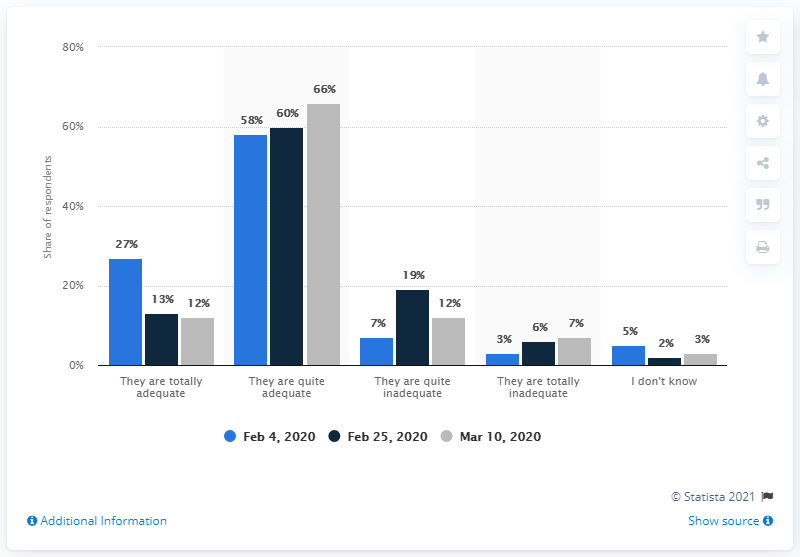Highlight a few significant elements in this photo. Thirty-eight people expressed their opinion that the given item is inadequate by stating 'They are quite inadequate.' A majority of people believed that the measures implemented by the Italian government were sufficient. What is the total percentage of people who do not know the answer to the question, with a range of 10? A majority of Italians, 66%, declared that the health measures against Coronavirus were adequate. 